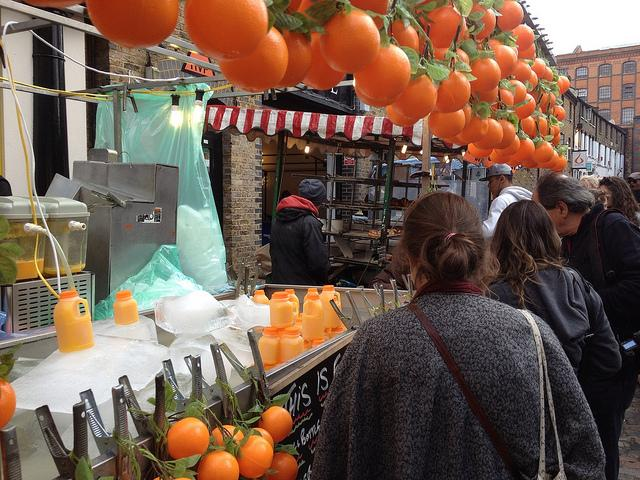The orange orbs seen here are actually what? oranges 